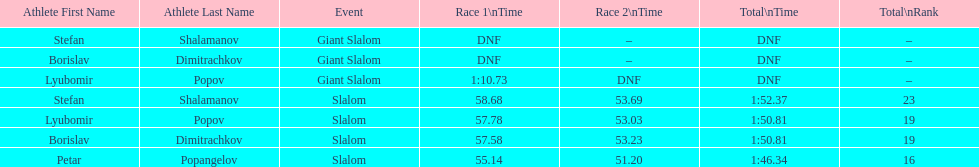How long did it take for lyubomir popov to finish the giant slalom in race 1? 1:10.73. 